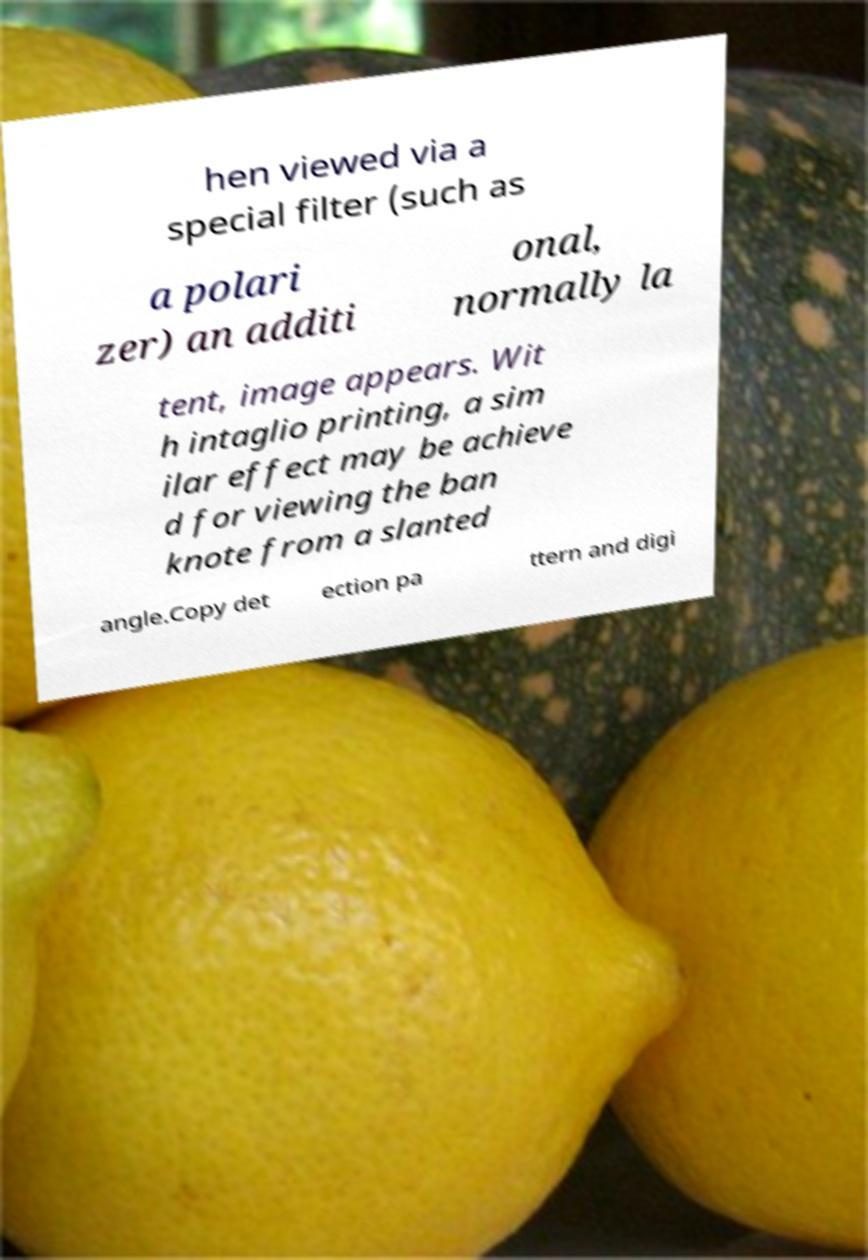Could you assist in decoding the text presented in this image and type it out clearly? hen viewed via a special filter (such as a polari zer) an additi onal, normally la tent, image appears. Wit h intaglio printing, a sim ilar effect may be achieve d for viewing the ban knote from a slanted angle.Copy det ection pa ttern and digi 